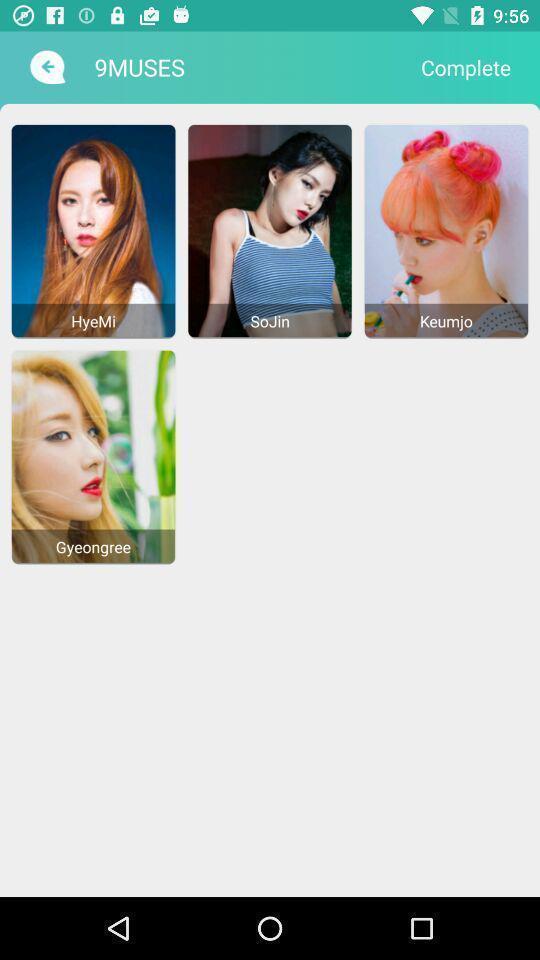What details can you identify in this image? Various images in the application. 